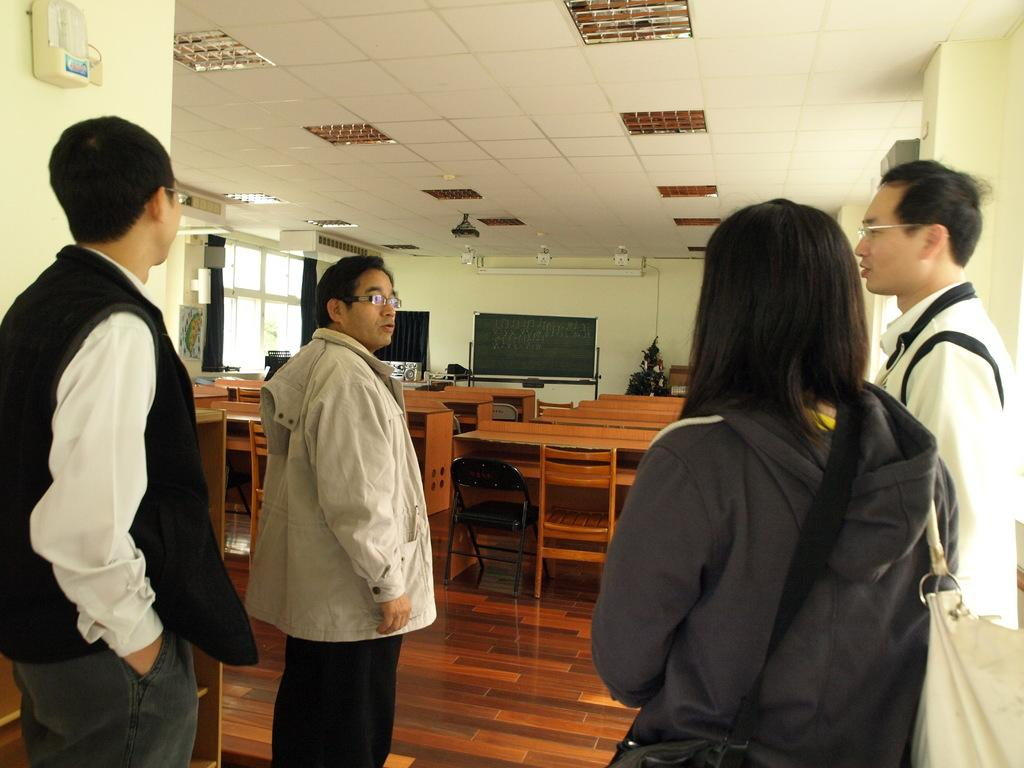How many people are in the room in the image? There are four people in the room. What is the source of light in the room? The room has a light. What type of furniture is present in the room? There are chairs in the room. Can you see any bees flying around in the room? There are no bees present in the image. Is there steam coming from any of the chairs in the room? There is no steam visible in the image. 